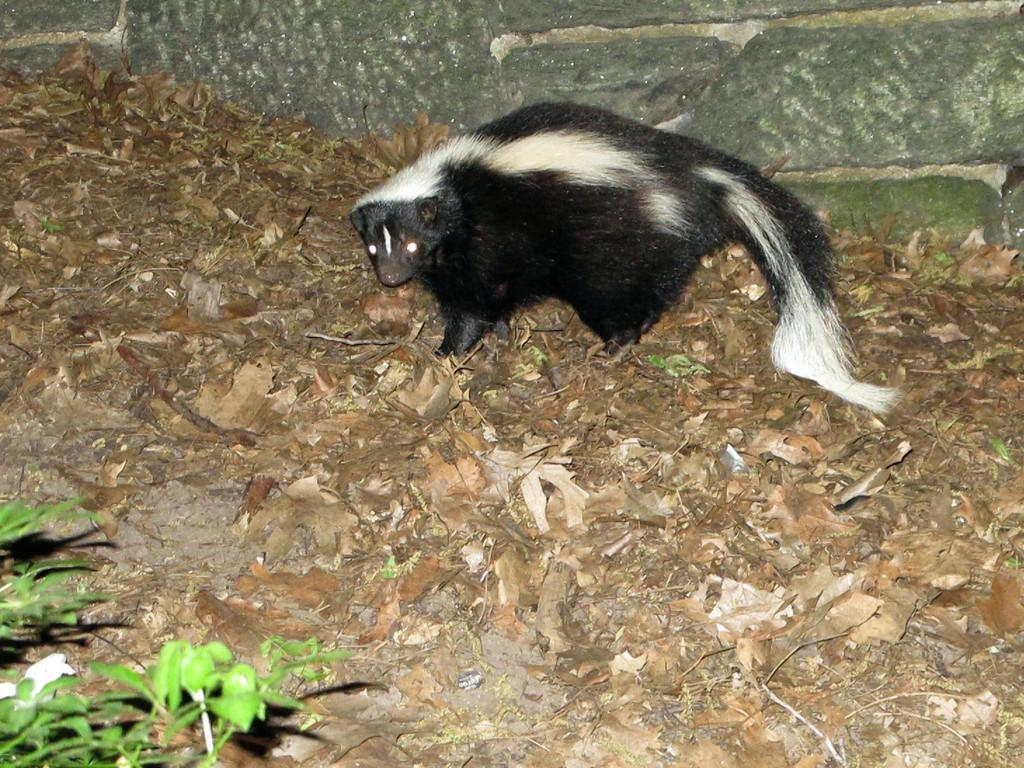What type of animal is in the image? There is an animal in the image, but its specific type is not mentioned in the facts. What color is the animal in the image? The animal is black and white in color. What is the animal's position in the image? The animal is standing on the ground. What is the ground like in the image? The ground has dry leaves and plants. What is near the animal in the image? There is a wall near the animal. What flavor of ice cream is the animal holding on a tray in the image? There is no ice cream or tray present in the image; the animal is standing on the ground with dry leaves and plants nearby. 